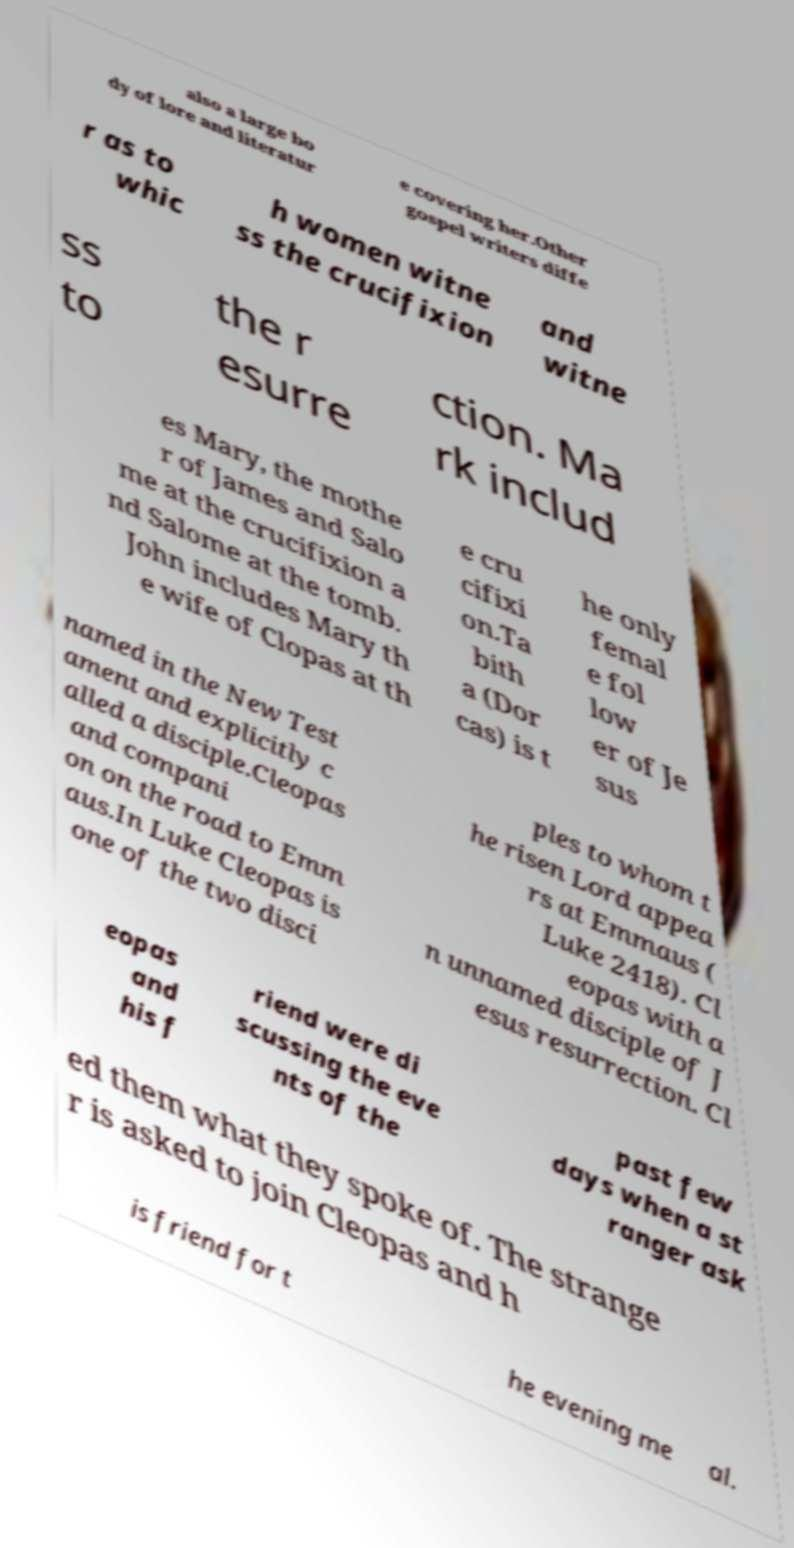Can you read and provide the text displayed in the image?This photo seems to have some interesting text. Can you extract and type it out for me? also a large bo dy of lore and literatur e covering her.Other gospel writers diffe r as to whic h women witne ss the crucifixion and witne ss to the r esurre ction. Ma rk includ es Mary, the mothe r of James and Salo me at the crucifixion a nd Salome at the tomb. John includes Mary th e wife of Clopas at th e cru cifixi on.Ta bith a (Dor cas) is t he only femal e fol low er of Je sus named in the New Test ament and explicitly c alled a disciple.Cleopas and compani on on the road to Emm aus.In Luke Cleopas is one of the two disci ples to whom t he risen Lord appea rs at Emmaus ( Luke 2418). Cl eopas with a n unnamed disciple of J esus resurrection. Cl eopas and his f riend were di scussing the eve nts of the past few days when a st ranger ask ed them what they spoke of. The strange r is asked to join Cleopas and h is friend for t he evening me al. 